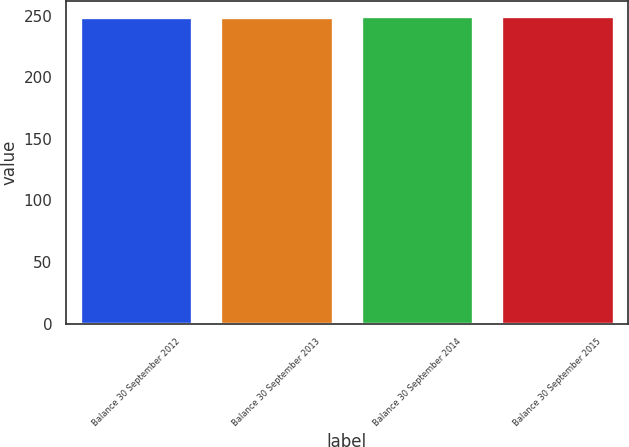Convert chart. <chart><loc_0><loc_0><loc_500><loc_500><bar_chart><fcel>Balance 30 September 2012<fcel>Balance 30 September 2013<fcel>Balance 30 September 2014<fcel>Balance 30 September 2015<nl><fcel>249.4<fcel>249.5<fcel>249.6<fcel>249.7<nl></chart> 